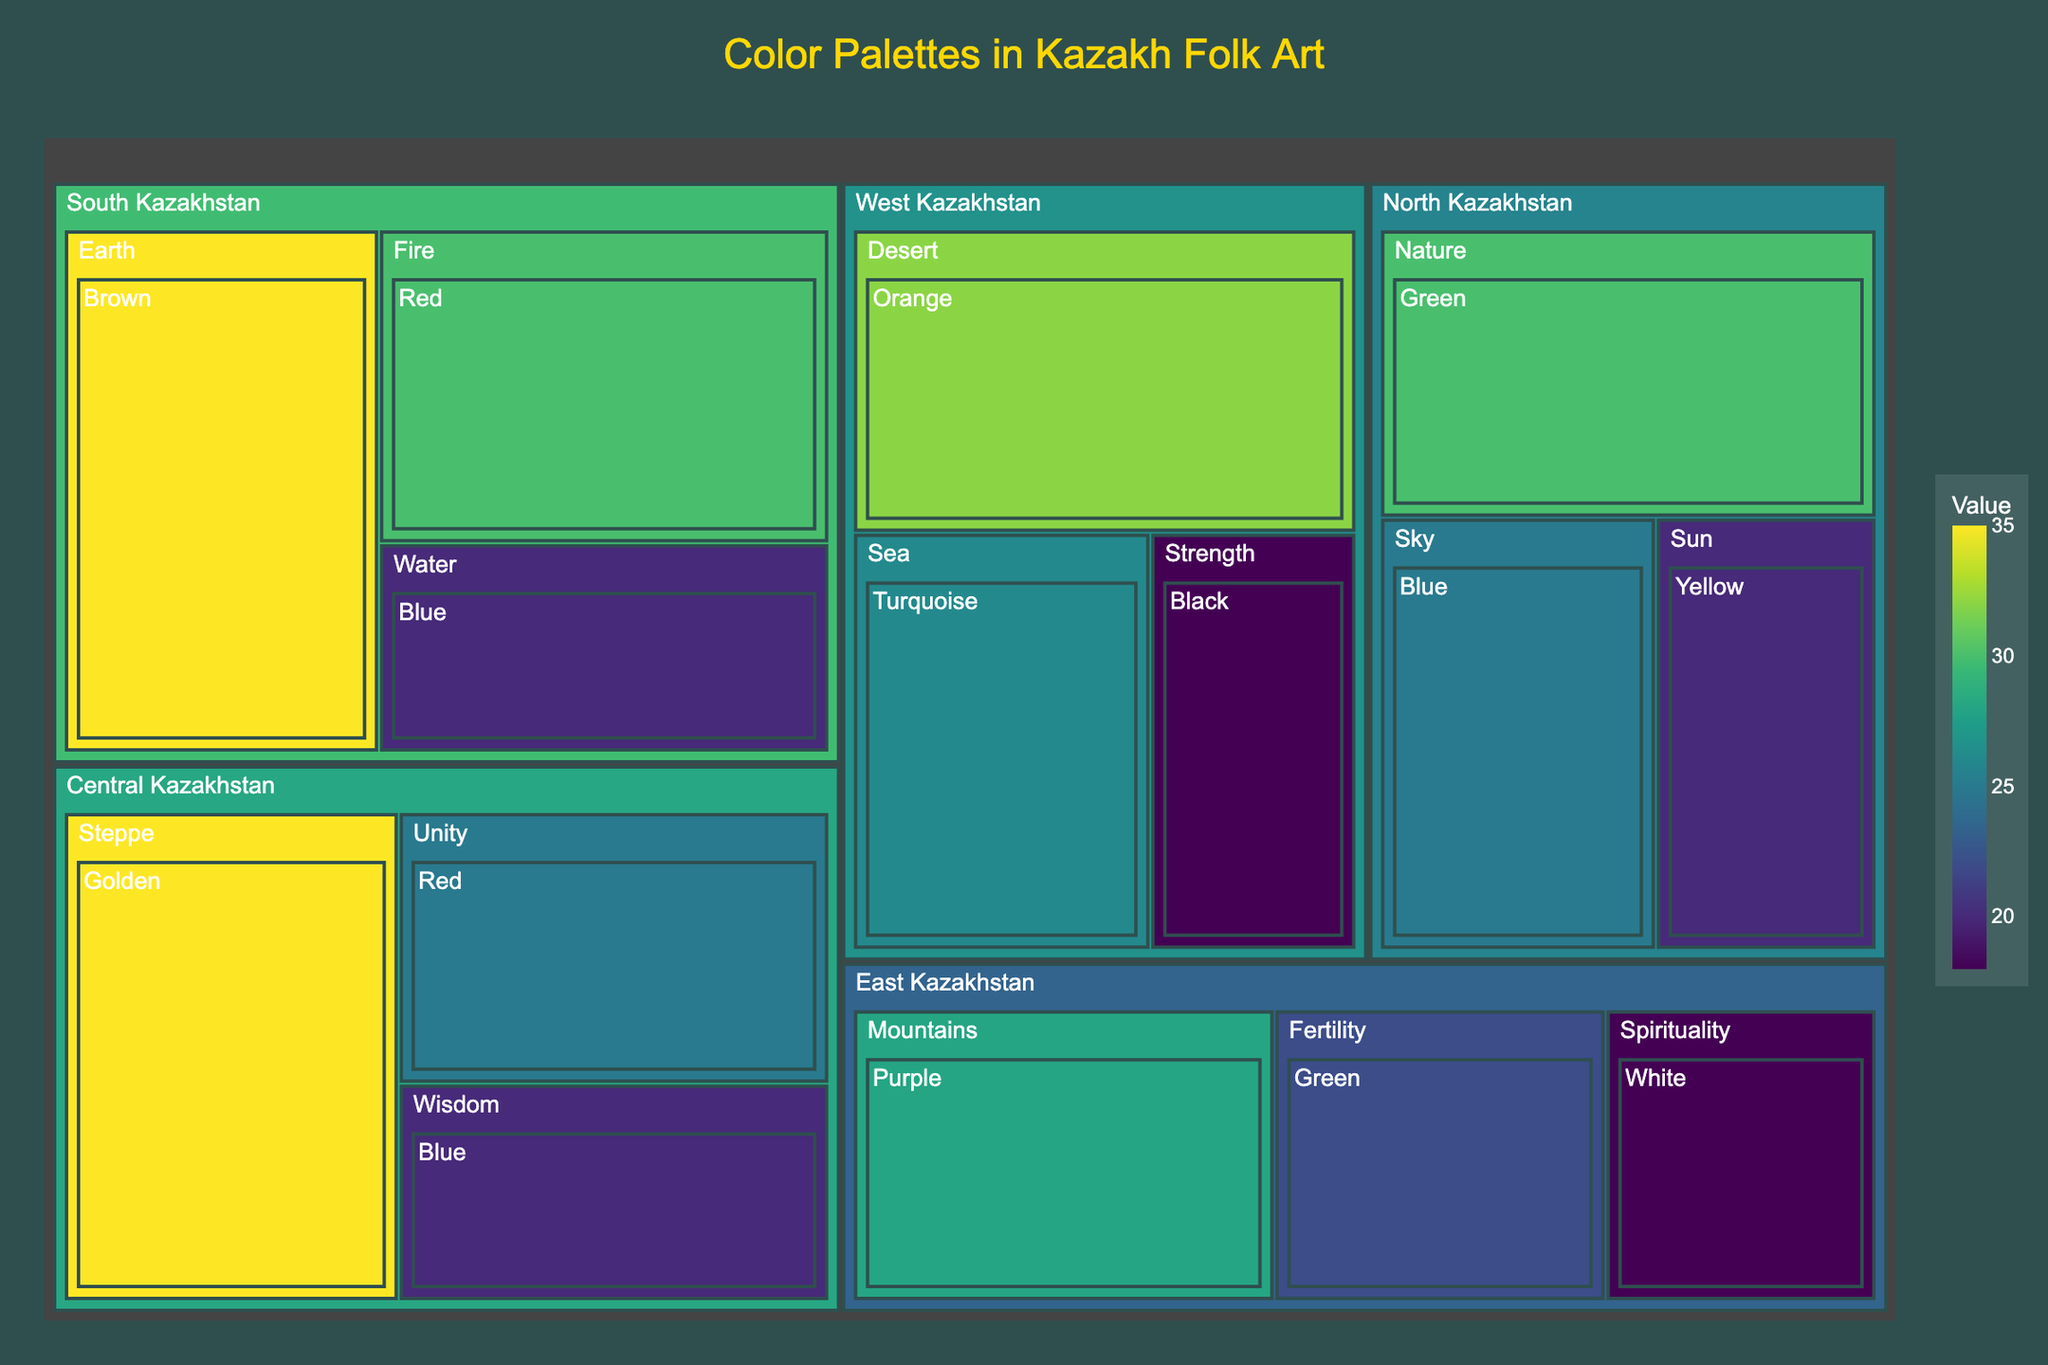What's the title of the treemap? The title is provided at the top of the treemap, usually in a larger or bold font.
Answer: Color Palettes in Kazakh Folk Art Which region has the highest value for the 'Fire' symbolism? The treemap is organized by regions, symbolism, and then colors. By locating the 'Fire' symbolism under each region, we can see which one has the highest value. In this case, 'Fire' only appears in South Kazakhstan.
Answer: South Kazakhstan What is the sum of values for the 'Green' color across all regions? We need to sum up all the values corresponding to the 'Green' color across different regions: 30 (North Kazakhstan) + 22 (East Kazakhstan) = 52.
Answer: 52 Which symbolism has the highest value in Central Kazakhstan? By examining the symbols under Central Kazakhstan, we note the values - Steppe: 35, Unity: 25, Wisdom: 20. The highest value is for 'Steppe' at 35.
Answer: Steppe Compare the value of 'Blue' color in North Kazakhstan vs Central Kazakhstan. Which one is higher? North Kazakhstan has a value of Blue (Sky) at 25. Central Kazakhstan has a value of Blue (Wisdom) at 20. Comparing these, North Kazakhstan has a higher value.
Answer: North Kazakhstan How many unique colors are used in the entire treemap dataset? By listing all the colors and counting unique entries, we see: Green, Blue, Yellow, Brown, Red, Purple, White, Orange, Turquoise, Black, Golden. Total unique colors are 11.
Answer: 11 What is the total value for West Kazakhstan? Add all the values under West Kazakhstan: Desert (32) + Sea (26) + Strength (18) = 32 + 26 + 18 = 76.
Answer: 76 What color represents 'Spirituality' in East Kazakhstan? By locating the 'Spirituality' symbolism under East Kazakhstan, we find the color associated with it: White.
Answer: White Is the value of 'Nature' in North Kazakhstan greater than the value of 'Fertility' in East Kazakhstan? In North Kazakhstan, 'Nature' has a value of 30. In East Kazakhstan, 'Fertility' has a value of 22. Since 30 is greater than 22, the answer is yes.
Answer: Yes 